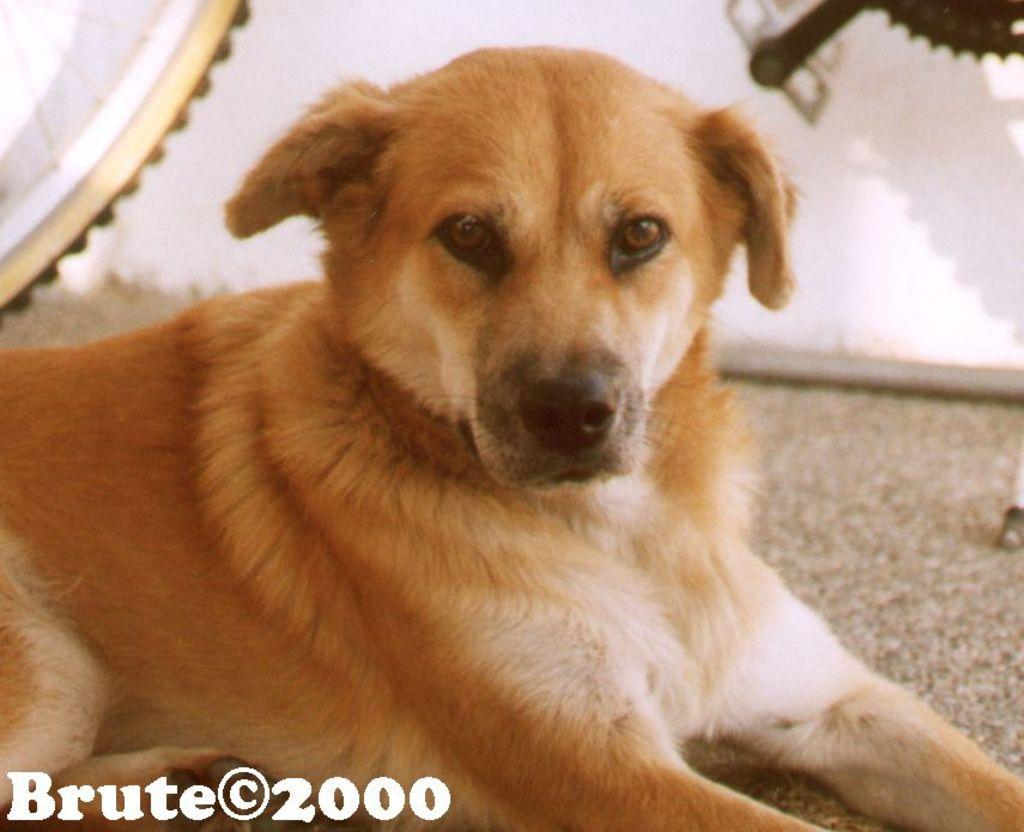What type of animal is in the image? There is a dog in the image. What other object can be seen in the image? There is a bicycle in the image. Where is the text located in the image? The text is at the bottom left side of the image. What type of sponge is being used by the yak in the image? There is no sponge or yak present in the image. What is the income of the person riding the bicycle in the image? There is no information about the person's income in the image. 